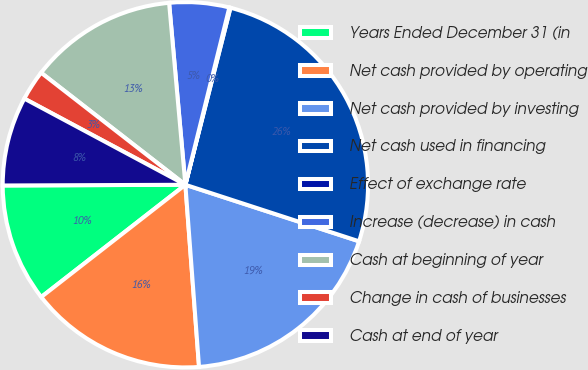Convert chart to OTSL. <chart><loc_0><loc_0><loc_500><loc_500><pie_chart><fcel>Years Ended December 31 (in<fcel>Net cash provided by operating<fcel>Net cash provided by investing<fcel>Net cash used in financing<fcel>Effect of exchange rate<fcel>Increase (decrease) in cash<fcel>Cash at beginning of year<fcel>Change in cash of businesses<fcel>Cash at end of year<nl><fcel>10.47%<fcel>15.66%<fcel>18.8%<fcel>26.04%<fcel>0.1%<fcel>5.29%<fcel>13.07%<fcel>2.69%<fcel>7.88%<nl></chart> 